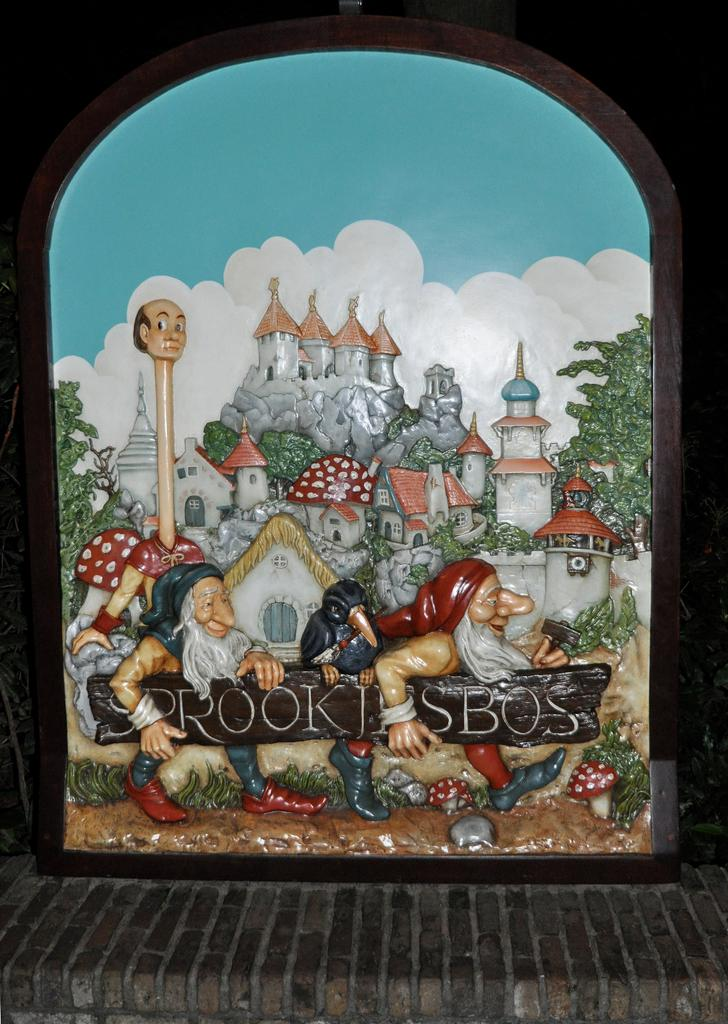What is depicted on the door in the image? There is a picture on the door in the image. What elements can be seen in the picture? The picture contains sky, clouds, buildings, trees, and poles. Are there any people in the picture? Yes, there are men on the ground in the picture. What type of neck accessory is worn by the trees in the image? There are no neck accessories worn by the trees in the image, as trees do not wear apparel. What type of apparel is worn by the men in the image? The provided facts do not mention the type of apparel worn by the men in the image. 